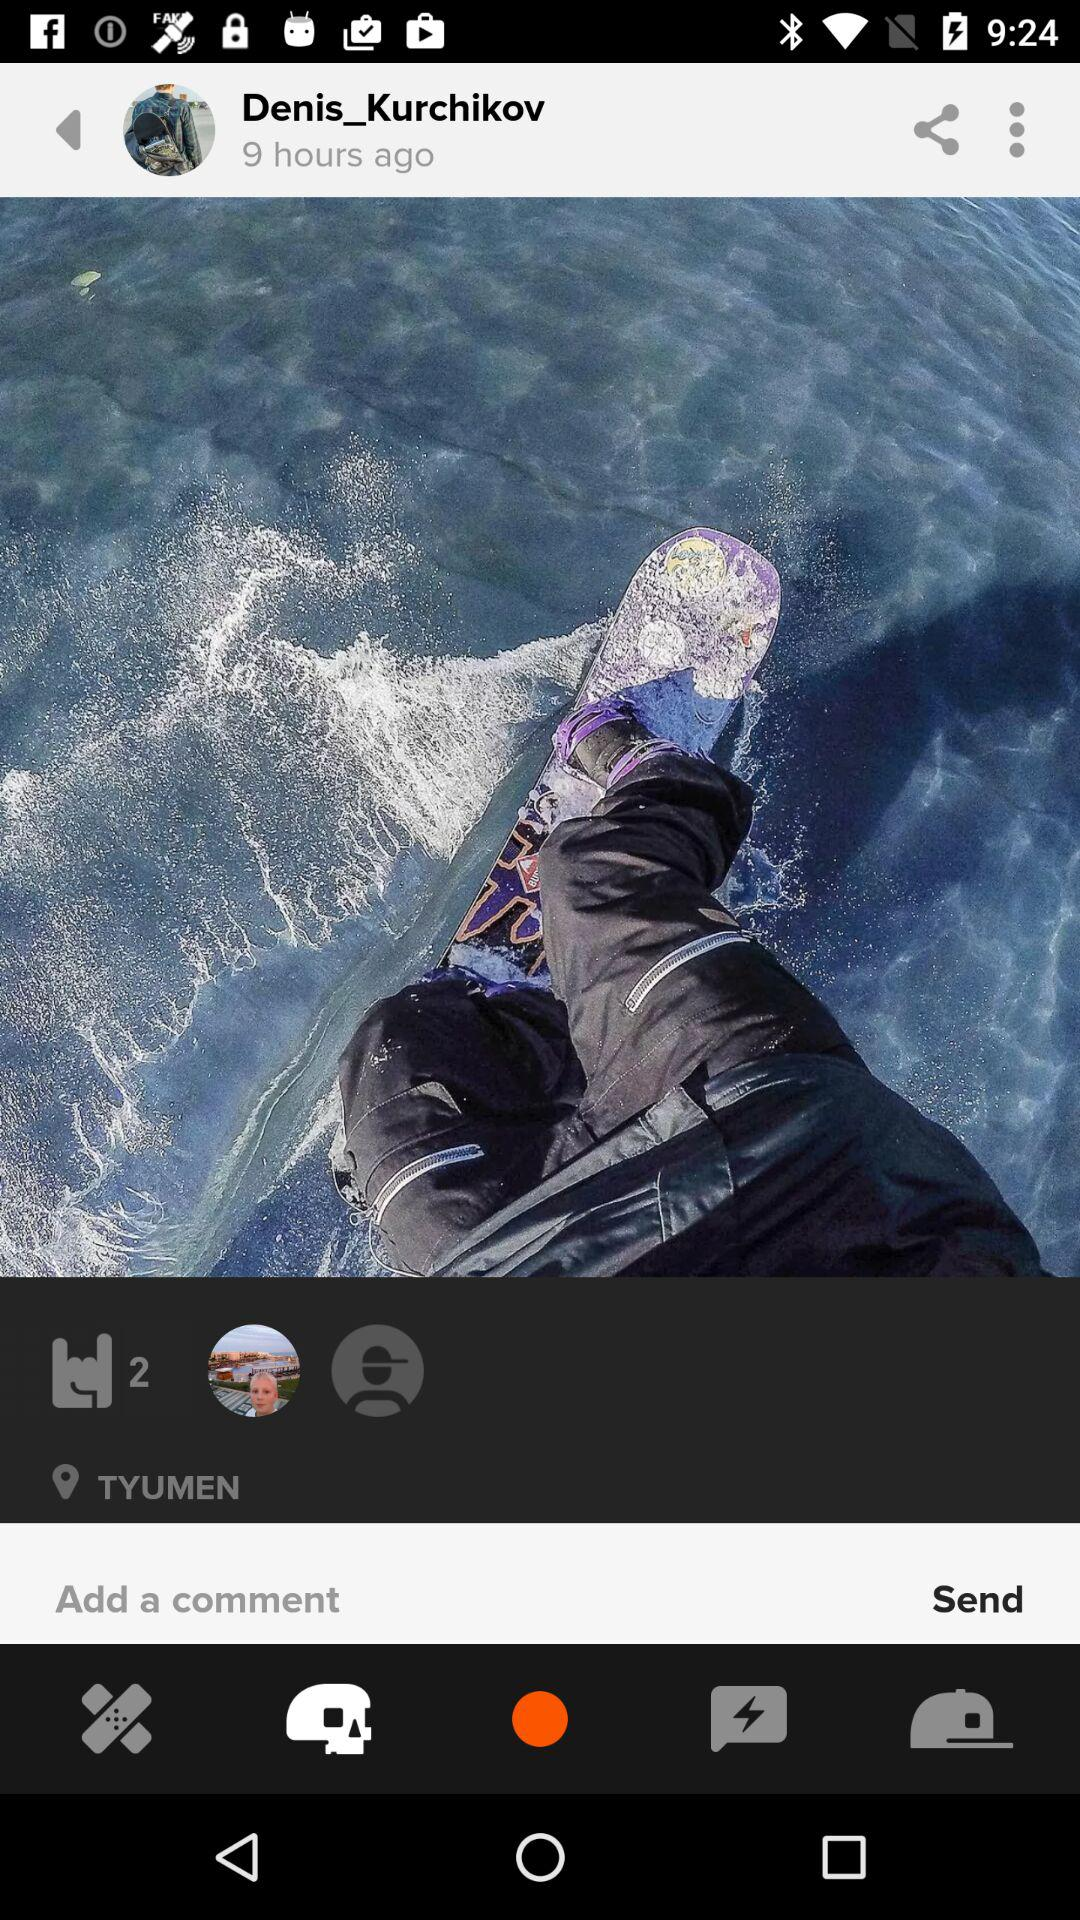How many more likes does the post have than comments?
Answer the question using a single word or phrase. 2 